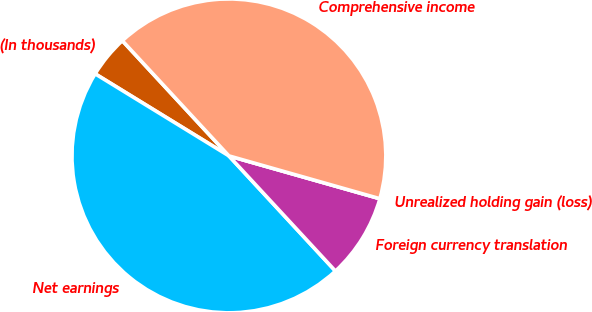Convert chart. <chart><loc_0><loc_0><loc_500><loc_500><pie_chart><fcel>(In thousands)<fcel>Net earnings<fcel>Foreign currency translation<fcel>Unrealized holding gain (loss)<fcel>Comprehensive income<nl><fcel>4.36%<fcel>45.64%<fcel>8.72%<fcel>0.0%<fcel>41.28%<nl></chart> 